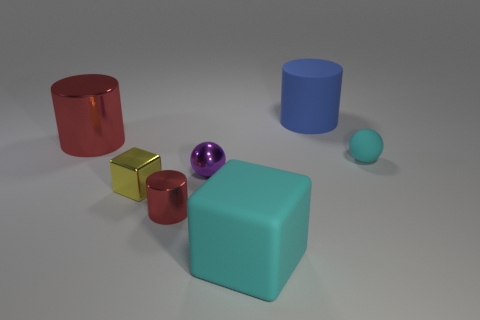How could these objects be used to explain basic geometry to children? These objects are ideal for illustrating basic geometric shapes such as cylinders, cubes, and spheres. Their varying sizes also provide a way to discuss scaling and proportions. What activity might utilize these shapes in a lesson? A possible activity could involve asking children to group the shapes by similarity, describe their attributes, and discuss how the shapes are used in everyday objects, reinforcing their understanding through tangible examples. 